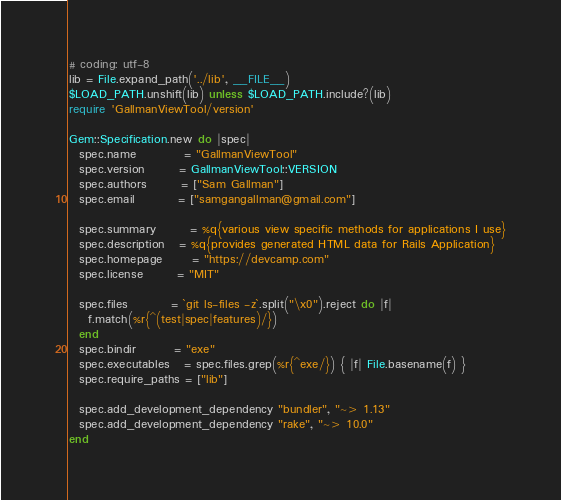Convert code to text. <code><loc_0><loc_0><loc_500><loc_500><_Ruby_># coding: utf-8
lib = File.expand_path('../lib', __FILE__)
$LOAD_PATH.unshift(lib) unless $LOAD_PATH.include?(lib)
require 'GallmanViewTool/version'

Gem::Specification.new do |spec|
  spec.name          = "GallmanViewTool"
  spec.version       = GallmanViewTool::VERSION
  spec.authors       = ["Sam Gallman"]
  spec.email         = ["samgangallman@gmail.com"]

  spec.summary       = %q{various view specific methods for applications I use}
  spec.description   = %q{provides generated HTML data for Rails Application}
  spec.homepage      = "https://devcamp.com"
  spec.license       = "MIT"

  spec.files         = `git ls-files -z`.split("\x0").reject do |f|
    f.match(%r{^(test|spec|features)/})
  end
  spec.bindir        = "exe"
  spec.executables   = spec.files.grep(%r{^exe/}) { |f| File.basename(f) }
  spec.require_paths = ["lib"]

  spec.add_development_dependency "bundler", "~> 1.13"
  spec.add_development_dependency "rake", "~> 10.0"
end
</code> 